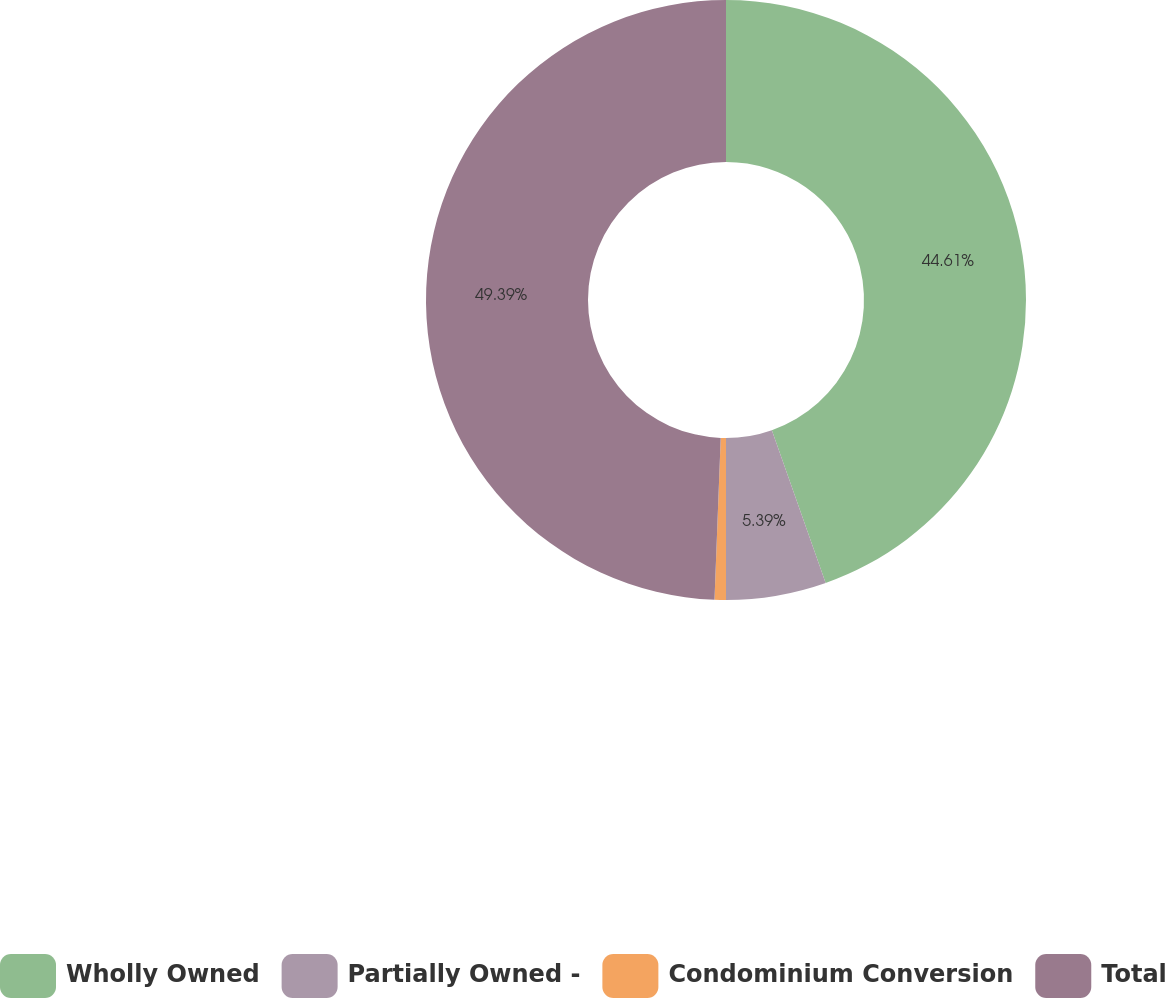Convert chart to OTSL. <chart><loc_0><loc_0><loc_500><loc_500><pie_chart><fcel>Wholly Owned<fcel>Partially Owned -<fcel>Condominium Conversion<fcel>Total<nl><fcel>44.61%<fcel>5.39%<fcel>0.61%<fcel>49.39%<nl></chart> 